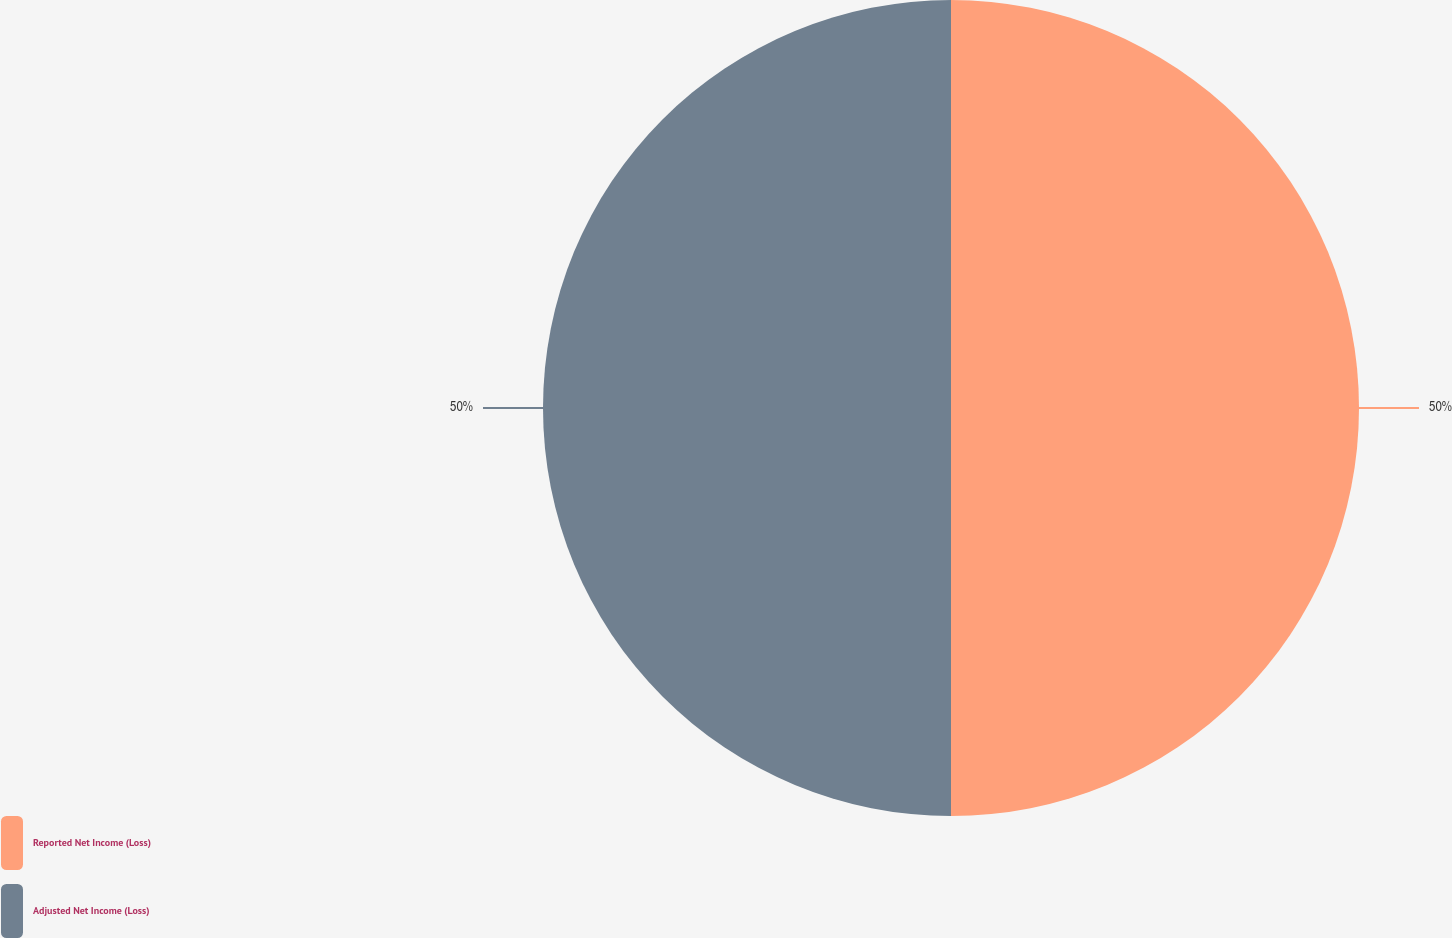<chart> <loc_0><loc_0><loc_500><loc_500><pie_chart><fcel>Reported Net Income (Loss)<fcel>Adjusted Net Income (Loss)<nl><fcel>50.0%<fcel>50.0%<nl></chart> 